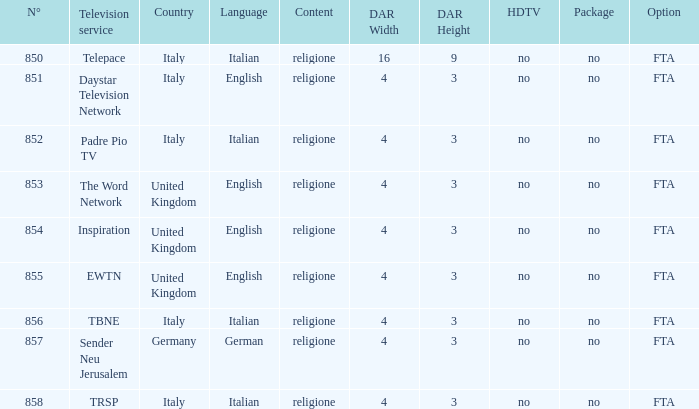What television service is in italy and is in english? Daystar Television Network. 